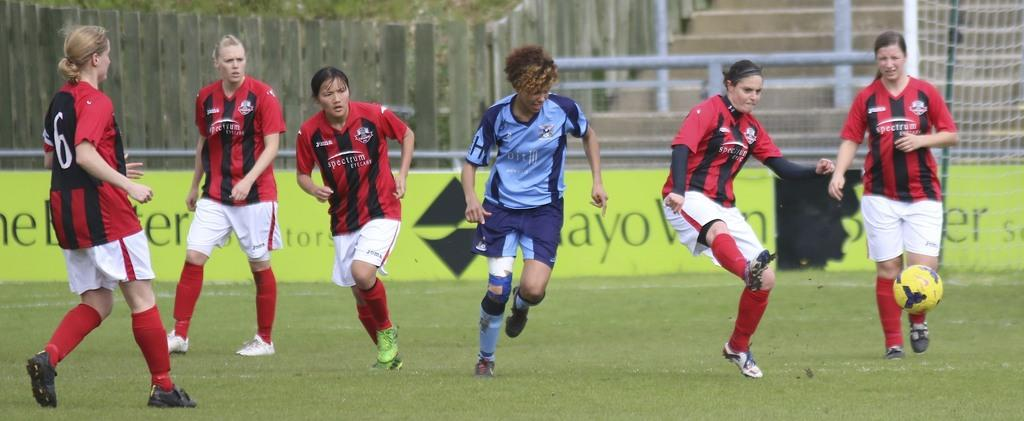How many people are in the image? There are many people in the image. What are the people wearing? The people are wearing clothes, socks, and shoes. What are the people doing in the image? The people are playing. What object can be seen in the image that is commonly used in sports? There is a ball in the image. What type of surface can be seen in the image? There is grass in the image. What is the purpose of the net in the image? The net is likely used to divide the playing area or to catch the ball. What architectural feature is present in the image? There are stairs in the image. What type of barrier is visible in the image? There is a wooden fence in the image. What type of business is being conducted in the image? There is no indication of a business being conducted in the image; it primarily features people playing. What letters are visible on the poster in the image? There is no information provided about the content of the poster, so we cannot determine what letters might be visible. 